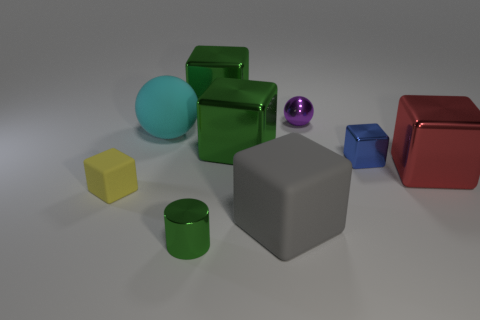What number of other objects are there of the same shape as the big red thing?
Provide a succinct answer. 5. Is the number of gray cubes in front of the green cylinder less than the number of large brown rubber objects?
Make the answer very short. No. There is a object to the left of the big cyan matte thing; what material is it?
Your answer should be compact. Rubber. What number of other objects are the same size as the cyan matte sphere?
Provide a short and direct response. 4. Are there fewer purple shiny things than blue matte balls?
Offer a terse response. No. The tiny yellow matte thing has what shape?
Offer a very short reply. Cube. There is a large thing that is behind the cyan sphere; does it have the same color as the metallic cylinder?
Your answer should be compact. Yes. What is the shape of the green shiny object that is in front of the small purple ball and behind the blue metal thing?
Your answer should be compact. Cube. The sphere left of the big gray object is what color?
Keep it short and to the point. Cyan. Is there anything else that is the same color as the cylinder?
Provide a succinct answer. Yes. 